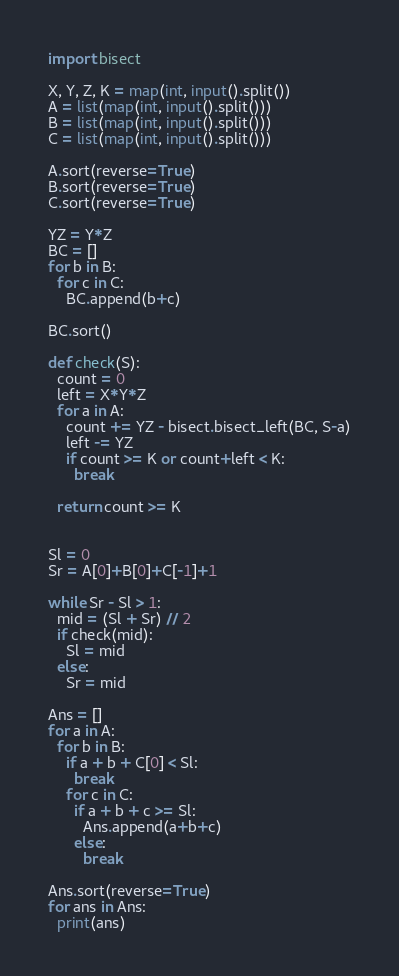Convert code to text. <code><loc_0><loc_0><loc_500><loc_500><_Python_>import bisect

X, Y, Z, K = map(int, input().split())
A = list(map(int, input().split()))
B = list(map(int, input().split()))
C = list(map(int, input().split()))

A.sort(reverse=True)
B.sort(reverse=True)
C.sort(reverse=True)

YZ = Y*Z
BC = []
for b in B:
  for c in C:
    BC.append(b+c)

BC.sort()

def check(S):
  count = 0
  left = X*Y*Z
  for a in A:
    count += YZ - bisect.bisect_left(BC, S-a)
    left -= YZ
    if count >= K or count+left < K:
      break
  
  return count >= K


Sl = 0
Sr = A[0]+B[0]+C[-1]+1

while Sr - Sl > 1:
  mid = (Sl + Sr) // 2
  if check(mid):
    Sl = mid
  else:
    Sr = mid

Ans = []
for a in A:
  for b in B:
    if a + b + C[0] < Sl:
      break
    for c in C:
      if a + b + c >= Sl:
        Ans.append(a+b+c)
      else:
        break

Ans.sort(reverse=True)
for ans in Ans:
  print(ans)</code> 